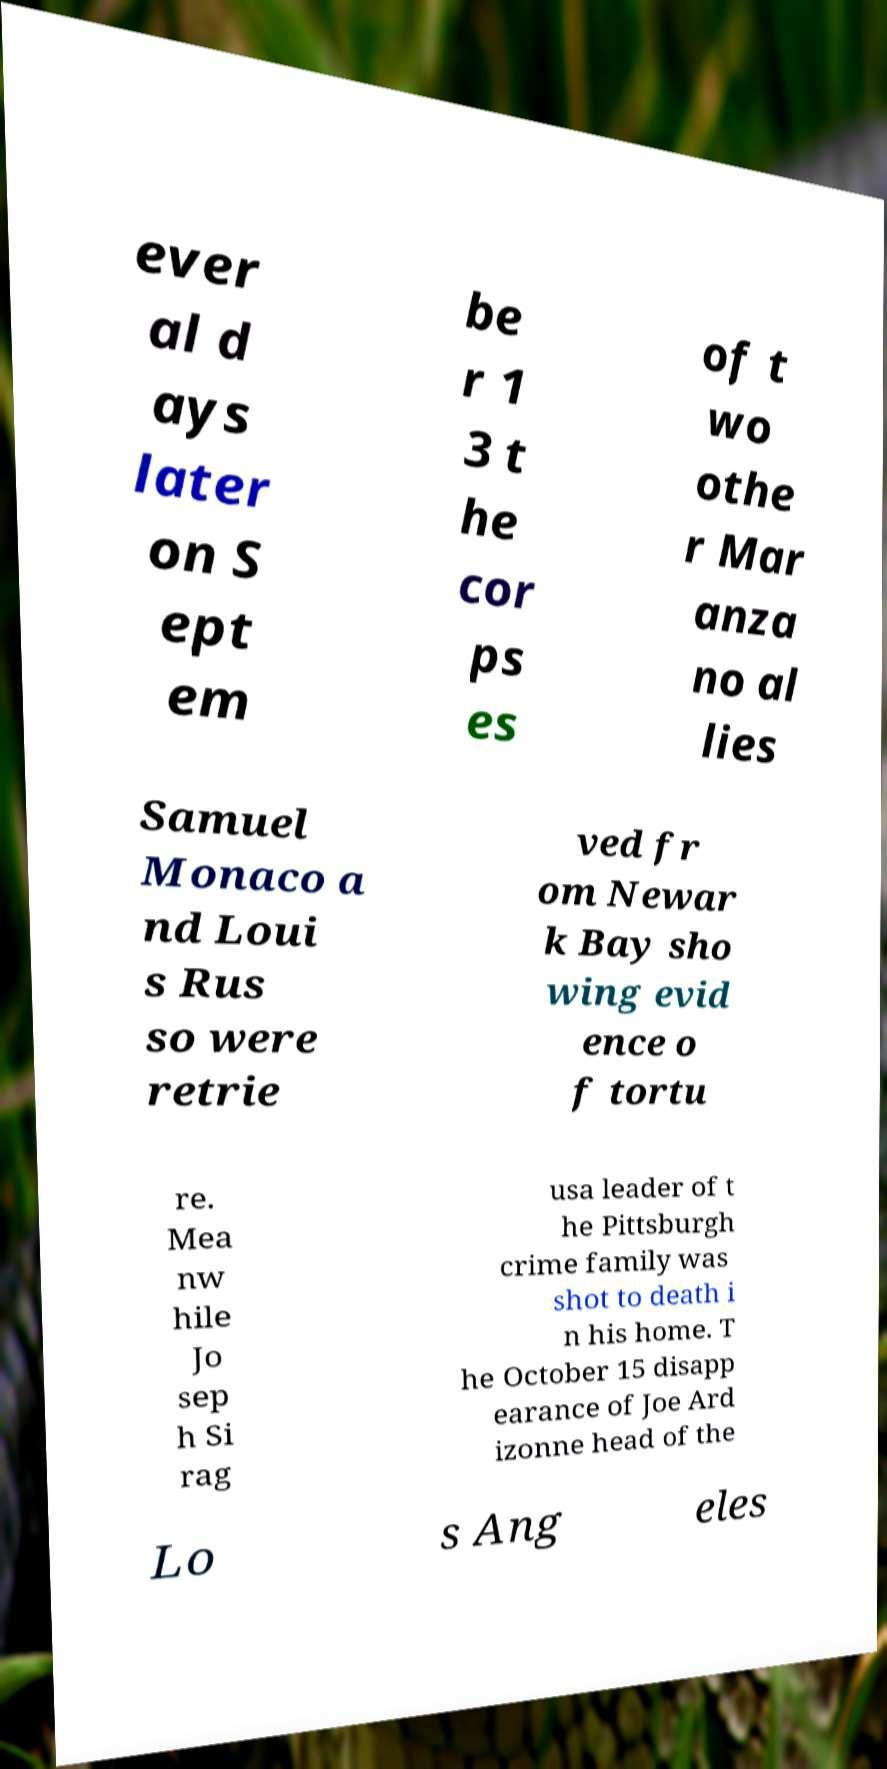Could you extract and type out the text from this image? ever al d ays later on S ept em be r 1 3 t he cor ps es of t wo othe r Mar anza no al lies Samuel Monaco a nd Loui s Rus so were retrie ved fr om Newar k Bay sho wing evid ence o f tortu re. Mea nw hile Jo sep h Si rag usa leader of t he Pittsburgh crime family was shot to death i n his home. T he October 15 disapp earance of Joe Ard izonne head of the Lo s Ang eles 